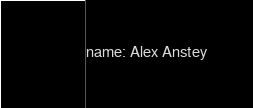Convert code to text. <code><loc_0><loc_0><loc_500><loc_500><_YAML_>name: Alex Anstey
</code> 